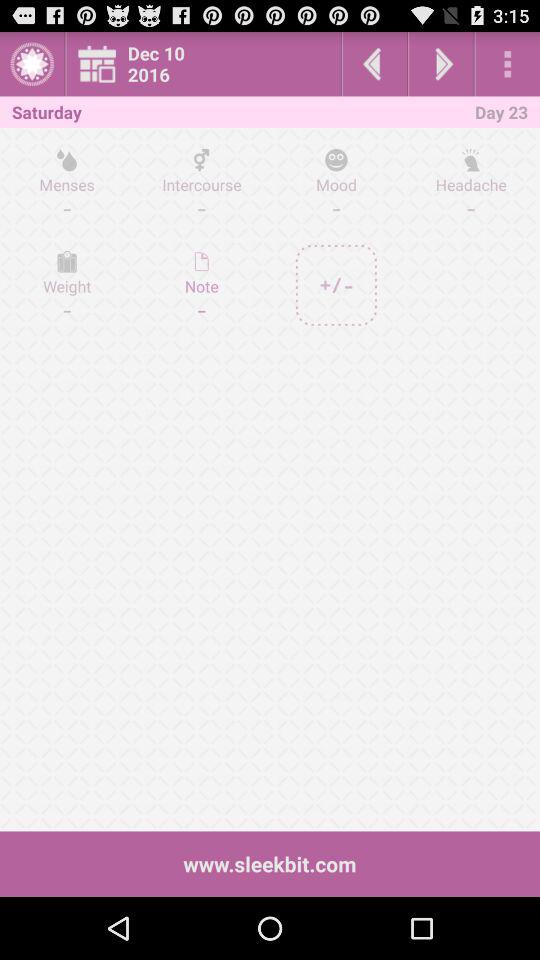What is the date? The date is Saturday, December 10, 2016. 